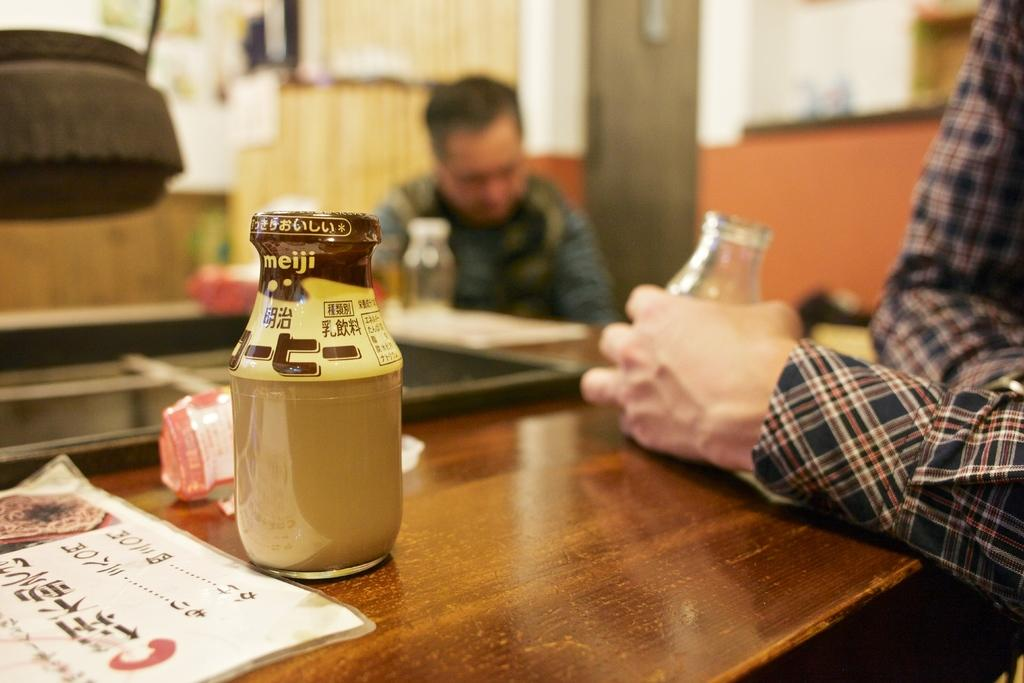What can be seen on the table in the image? There is a bottle and other objects on the table in the image. How many people are in the image? There are two men in the image. What are the men holding in their hands? The men are holding glasses in their hands. What type of money is being exchanged between the men in the image? There is no indication of money or any exchange taking place in the image. What type of tools might the carpenter be using in the image? There is no carpenter or any tools present in the image. 